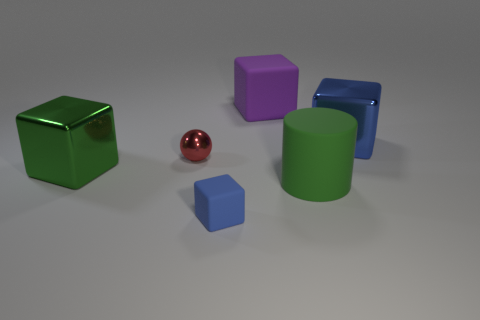The metallic object that is the same color as the cylinder is what shape?
Make the answer very short. Cube. Does the rubber cube in front of the large green metallic object have the same color as the matte thing behind the green shiny thing?
Offer a very short reply. No. What size is the thing that is the same color as the tiny block?
Your answer should be compact. Large. Are there any tiny matte blocks?
Your answer should be compact. Yes. The thing that is on the right side of the large green cylinder that is to the right of the tiny thing that is in front of the big green shiny cube is what shape?
Provide a short and direct response. Cube. There is a large blue metal thing; what number of big blue things are on the right side of it?
Offer a very short reply. 0. Does the purple block behind the cylinder have the same material as the green cube?
Your response must be concise. No. What number of other objects are the same shape as the green metal object?
Ensure brevity in your answer.  3. There is a big shiny thing to the left of the large matte thing that is behind the tiny metal thing; how many metallic spheres are to the right of it?
Your answer should be very brief. 1. There is a metallic block that is on the left side of the small blue matte object; what is its color?
Keep it short and to the point. Green. 